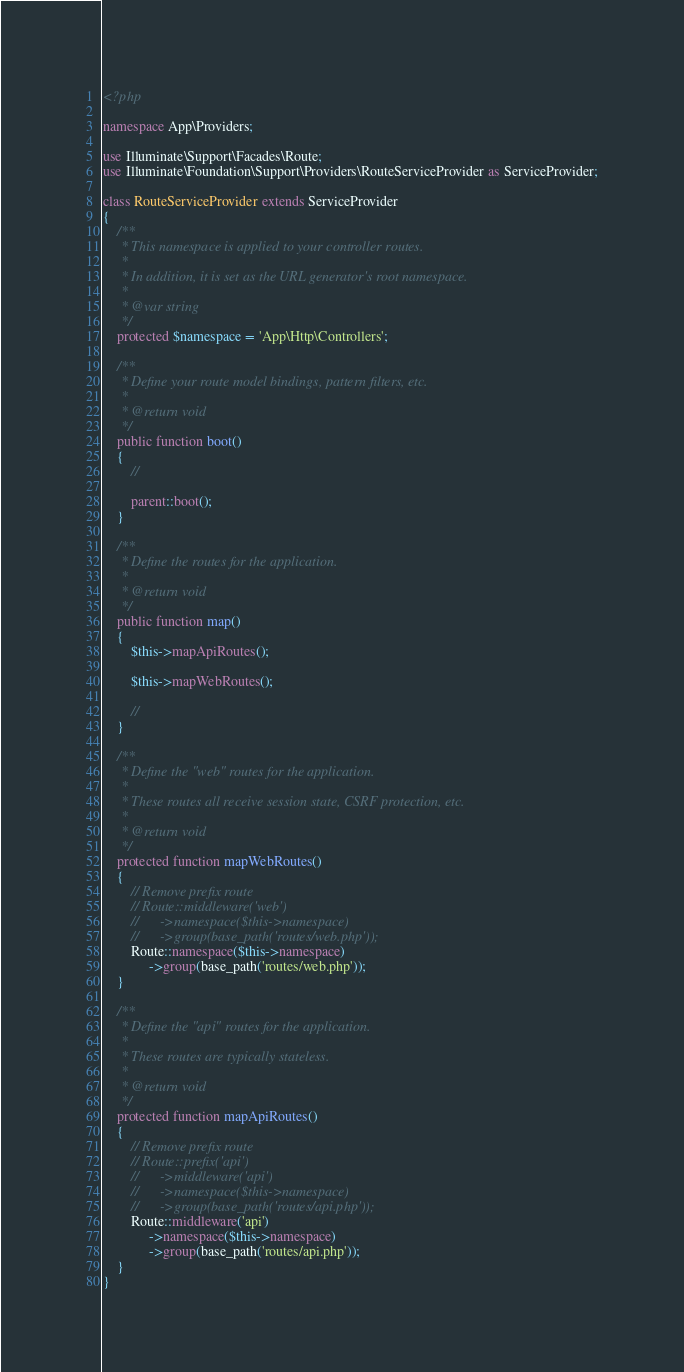<code> <loc_0><loc_0><loc_500><loc_500><_PHP_><?php

namespace App\Providers;

use Illuminate\Support\Facades\Route;
use Illuminate\Foundation\Support\Providers\RouteServiceProvider as ServiceProvider;

class RouteServiceProvider extends ServiceProvider
{
    /**
     * This namespace is applied to your controller routes.
     *
     * In addition, it is set as the URL generator's root namespace.
     *
     * @var string
     */
    protected $namespace = 'App\Http\Controllers';

    /**
     * Define your route model bindings, pattern filters, etc.
     *
     * @return void
     */
    public function boot()
    {
        //

        parent::boot();
    }

    /**
     * Define the routes for the application.
     *
     * @return void
     */
    public function map()
    {
        $this->mapApiRoutes();

        $this->mapWebRoutes();

        //
    }

    /**
     * Define the "web" routes for the application.
     *
     * These routes all receive session state, CSRF protection, etc.
     *
     * @return void
     */
    protected function mapWebRoutes()
    {
        // Remove prefix route
        // Route::middleware('web')
        //      ->namespace($this->namespace)
        //      ->group(base_path('routes/web.php'));
        Route::namespace($this->namespace)
             ->group(base_path('routes/web.php'));
    }

    /**
     * Define the "api" routes for the application.
     *
     * These routes are typically stateless.
     *
     * @return void
     */
    protected function mapApiRoutes()
    {
        // Remove prefix route
        // Route::prefix('api')
        //      ->middleware('api')
        //      ->namespace($this->namespace)
        //      ->group(base_path('routes/api.php'));
        Route::middleware('api')
             ->namespace($this->namespace)
             ->group(base_path('routes/api.php'));
    }
}
</code> 